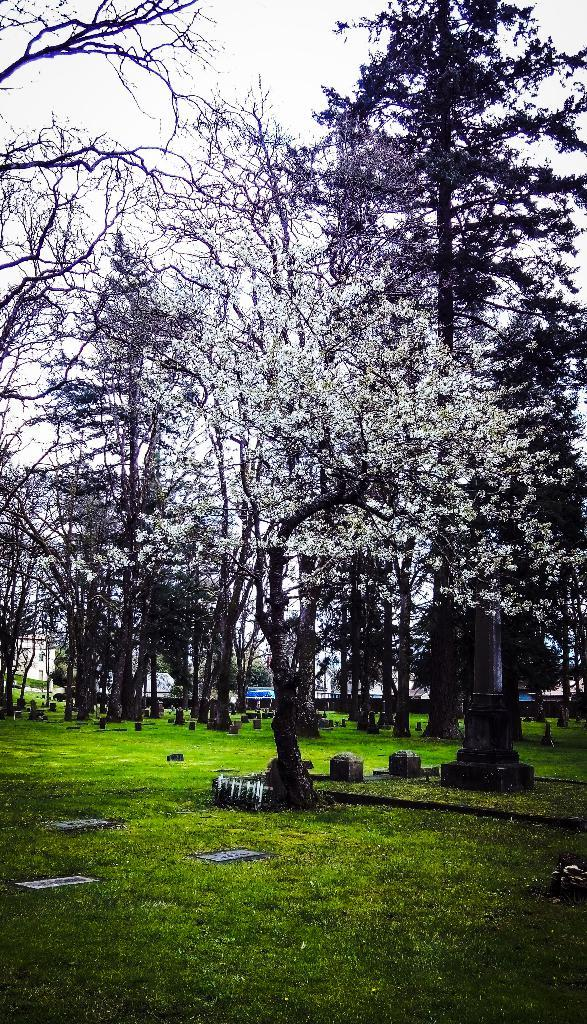What type of vegetation is at the bottom of the image? There is grass at the bottom of the image. What can be seen in the middle of the image? There are trees and graves in the middle of the image. What is present in the background of the image? There are trees, graves, and buildings in the background of the image. What is visible at the top of the image? The sky is visible at the top of the image. Can you see a person wearing linen in the image? There is no person wearing linen present in the image. What phase is the moon in the image? There is no moon present in the image. 